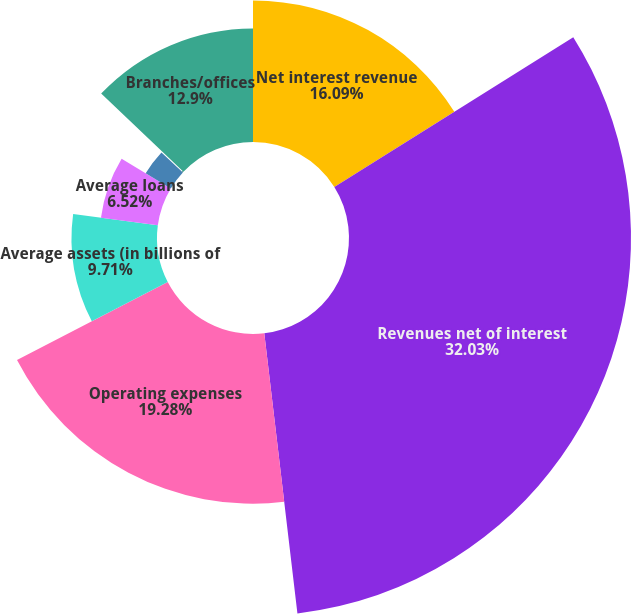Convert chart to OTSL. <chart><loc_0><loc_0><loc_500><loc_500><pie_chart><fcel>Net interest revenue<fcel>Revenues net of interest<fcel>Operating expenses<fcel>Average assets (in billions of<fcel>Average loans<fcel>Average Consumer Banking loans<fcel>Average deposits (and other<fcel>Branches/offices<nl><fcel>16.09%<fcel>32.04%<fcel>19.28%<fcel>9.71%<fcel>6.52%<fcel>3.33%<fcel>0.14%<fcel>12.9%<nl></chart> 